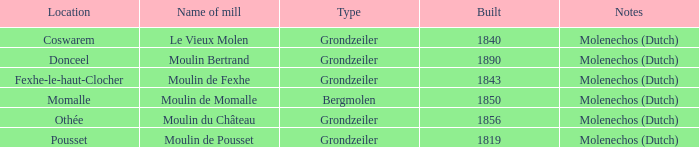Could you parse the entire table? {'header': ['Location', 'Name of mill', 'Type', 'Built', 'Notes'], 'rows': [['Coswarem', 'Le Vieux Molen', 'Grondzeiler', '1840', 'Molenechos (Dutch)'], ['Donceel', 'Moulin Bertrand', 'Grondzeiler', '1890', 'Molenechos (Dutch)'], ['Fexhe-le-haut-Clocher', 'Moulin de Fexhe', 'Grondzeiler', '1843', 'Molenechos (Dutch)'], ['Momalle', 'Moulin de Momalle', 'Bergmolen', '1850', 'Molenechos (Dutch)'], ['Othée', 'Moulin du Château', 'Grondzeiler', '1856', 'Molenechos (Dutch)'], ['Pousset', 'Moulin de Pousset', 'Grondzeiler', '1819', 'Molenechos (Dutch)']]} What is the Name of the Grondzeiler Mill? Le Vieux Molen, Moulin Bertrand, Moulin de Fexhe, Moulin du Château, Moulin de Pousset. 